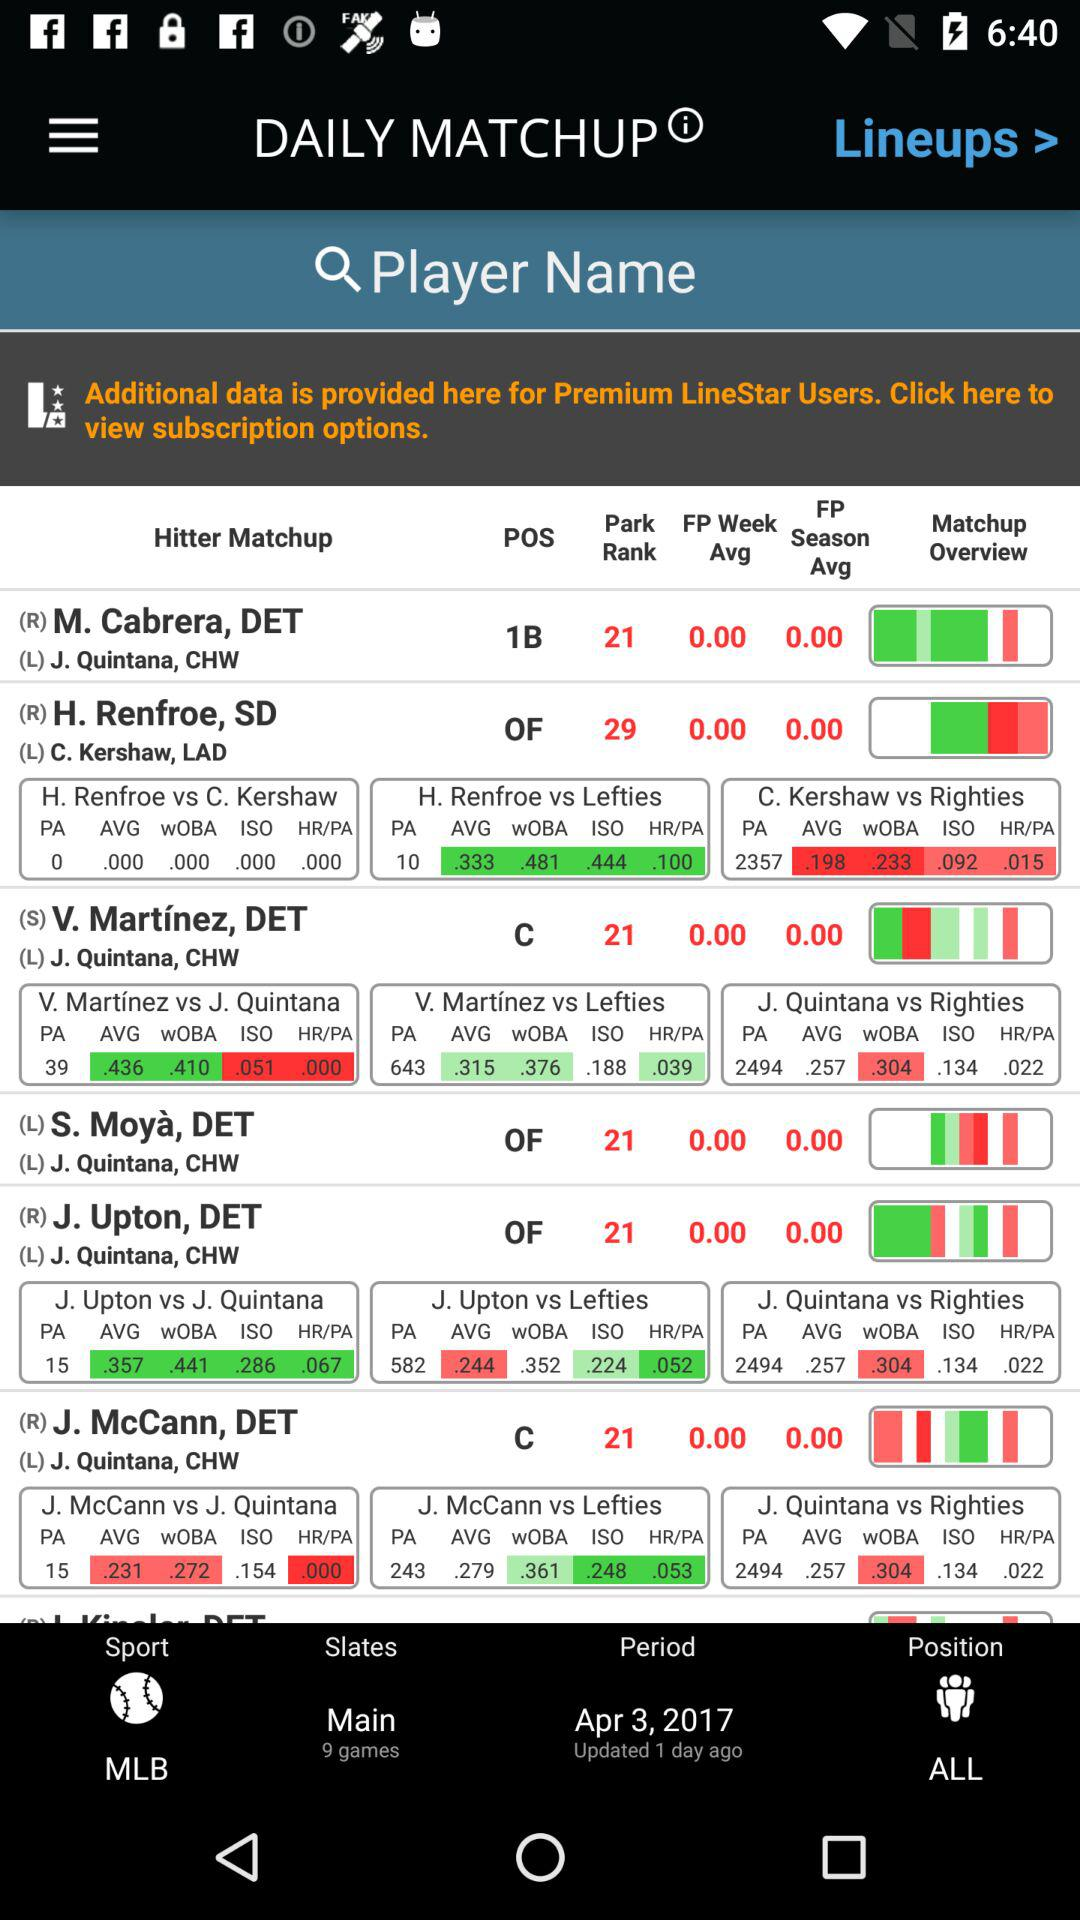What is the name of the application? The name of the application is "LineStar". 